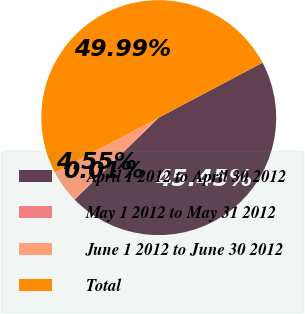Convert chart to OTSL. <chart><loc_0><loc_0><loc_500><loc_500><pie_chart><fcel>April 1 2012 to April 30 2012<fcel>May 1 2012 to May 31 2012<fcel>June 1 2012 to June 30 2012<fcel>Total<nl><fcel>45.45%<fcel>0.01%<fcel>4.55%<fcel>49.99%<nl></chart> 